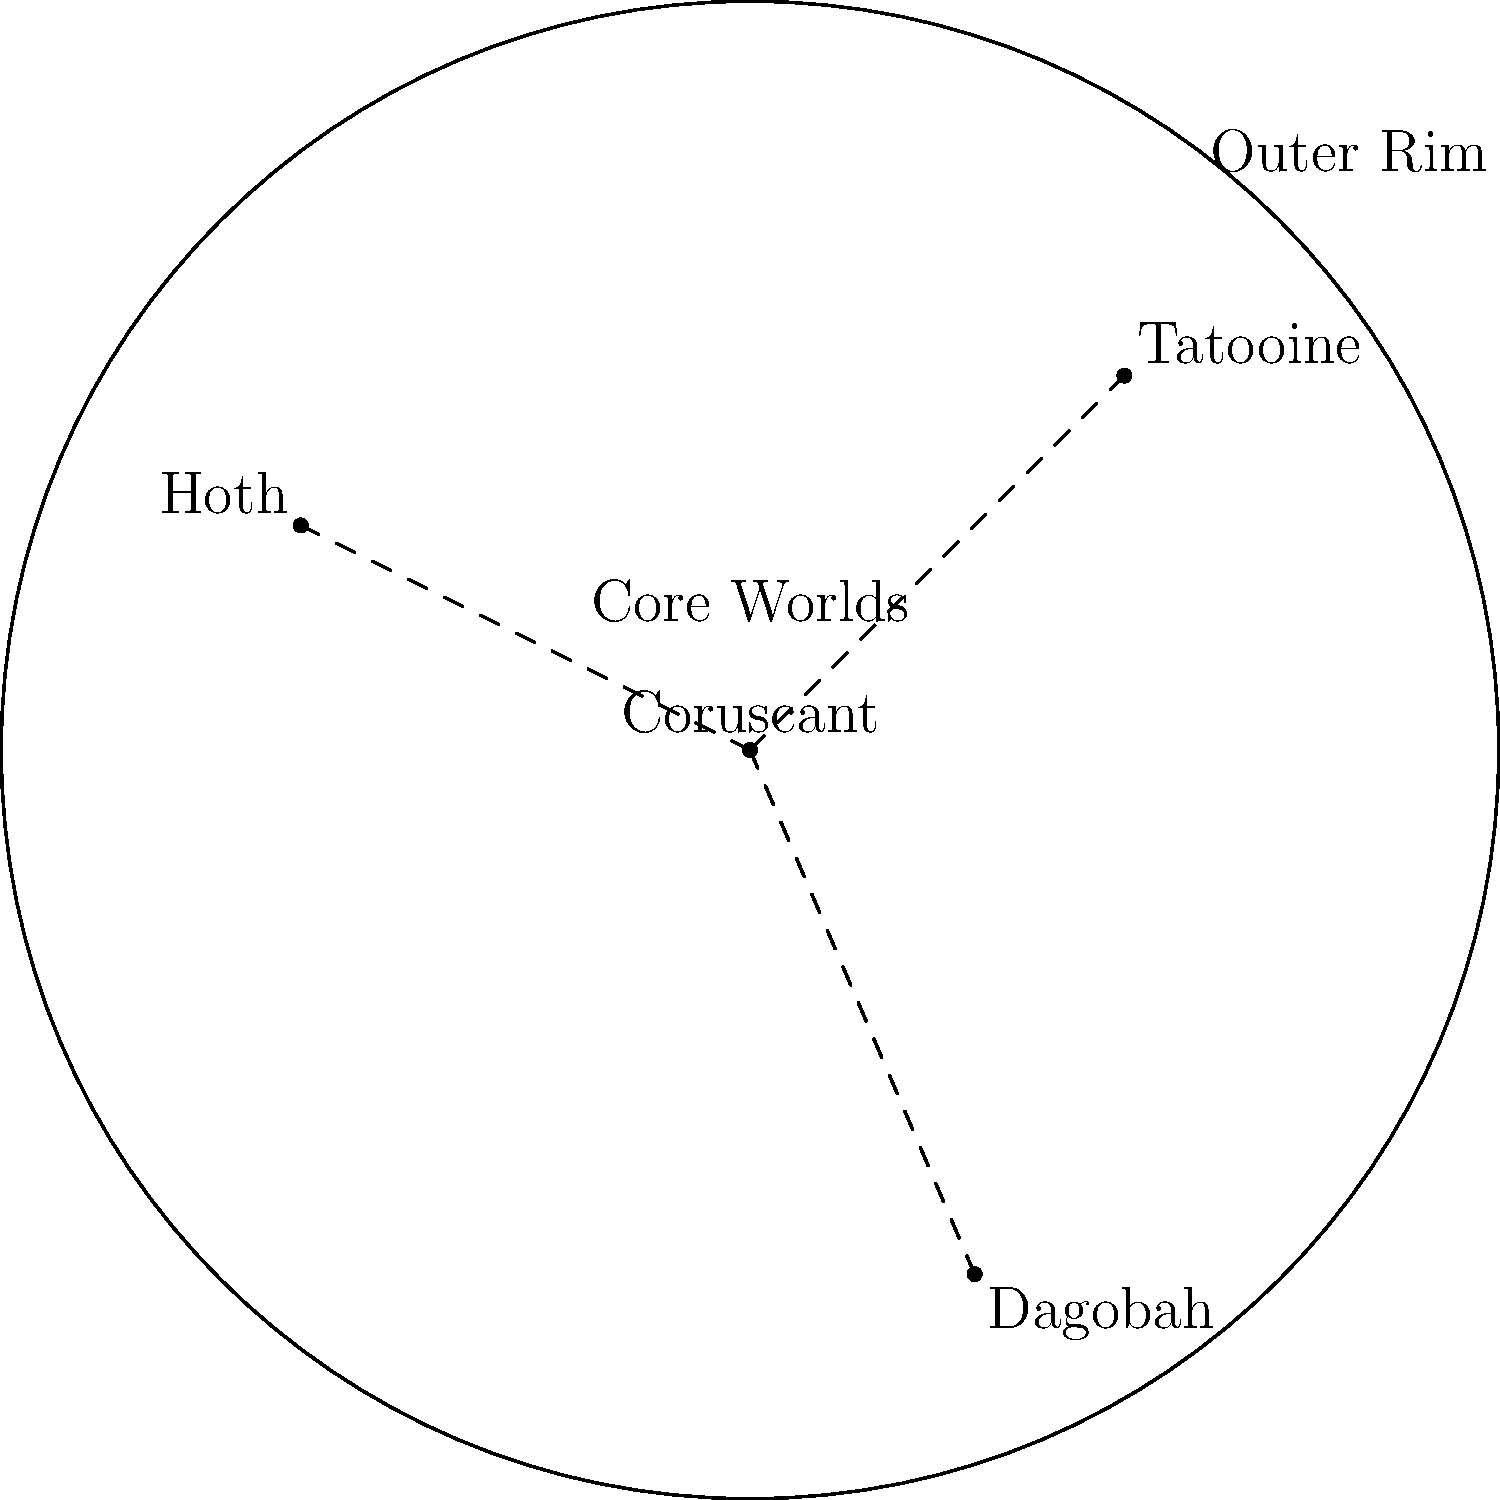In the map of the Star Wars galaxy, which planet is located in the Outer Rim and is known for its harsh desert environment, where Luke Skywalker grew up? To answer this question, let's analyze the map and our knowledge of Star Wars lore:

1. The map shows four key planets: Coruscant, Tatooine, Hoth, and Dagobah.

2. Coruscant is at the center, representing the Core Worlds.

3. The Outer Rim is labeled in the upper right corner of the map.

4. Tatooine is positioned in the upper right quadrant, closest to the "Outer Rim" label.

5. In Star Wars lore, Tatooine is known for its harsh desert environment and twin suns.

6. Luke Skywalker, the main protagonist of the original trilogy, grew up on Tatooine with his aunt and uncle.

7. The other planets don't match the description:
   - Hoth is an ice planet
   - Dagobah is a swamp planet
   - Coruscant is an ecumenopolis (city-covered planet) in the Core Worlds

Therefore, the planet that fits the description in the question is Tatooine.
Answer: Tatooine 